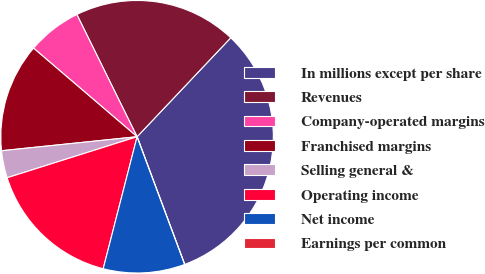Convert chart. <chart><loc_0><loc_0><loc_500><loc_500><pie_chart><fcel>In millions except per share<fcel>Revenues<fcel>Company-operated margins<fcel>Franchised margins<fcel>Selling general &<fcel>Operating income<fcel>Net income<fcel>Earnings per common<nl><fcel>32.26%<fcel>19.35%<fcel>6.45%<fcel>12.9%<fcel>3.23%<fcel>16.13%<fcel>9.68%<fcel>0.0%<nl></chart> 